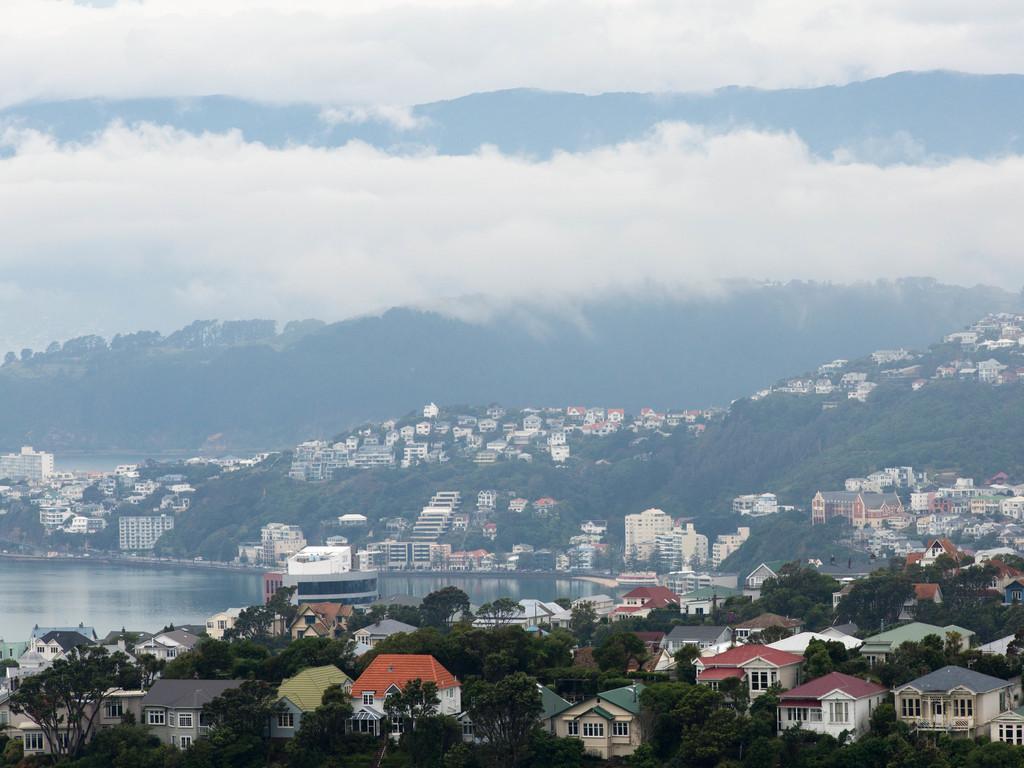How would you summarize this image in a sentence or two? In this image we can see group of building with windows, a group of trees and some hills. On the left side of the image we can see water. At the top of the image we can see the cloudy sky. 